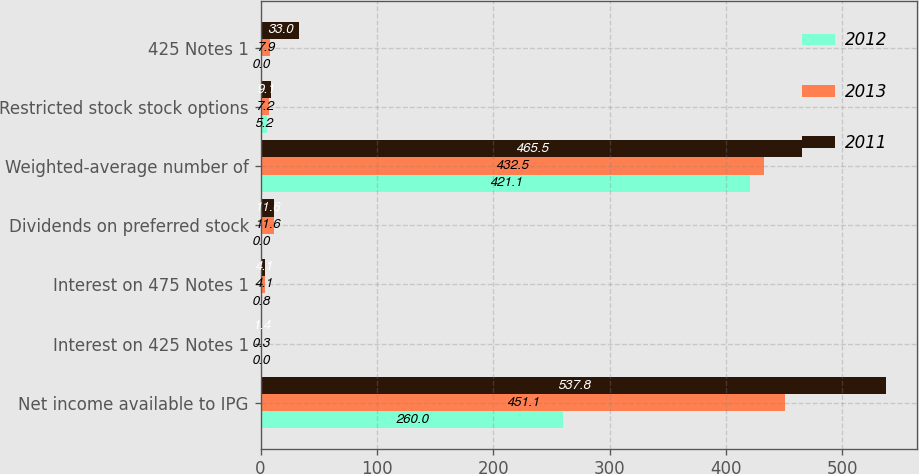<chart> <loc_0><loc_0><loc_500><loc_500><stacked_bar_chart><ecel><fcel>Net income available to IPG<fcel>Interest on 425 Notes 1<fcel>Interest on 475 Notes 1<fcel>Dividends on preferred stock<fcel>Weighted-average number of<fcel>Restricted stock stock options<fcel>425 Notes 1<nl><fcel>2012<fcel>260<fcel>0<fcel>0.8<fcel>0<fcel>421.1<fcel>5.2<fcel>0<nl><fcel>2013<fcel>451.1<fcel>0.3<fcel>4.1<fcel>11.6<fcel>432.5<fcel>7.2<fcel>7.9<nl><fcel>2011<fcel>537.8<fcel>1.4<fcel>4.1<fcel>11.6<fcel>465.5<fcel>9.1<fcel>33<nl></chart> 